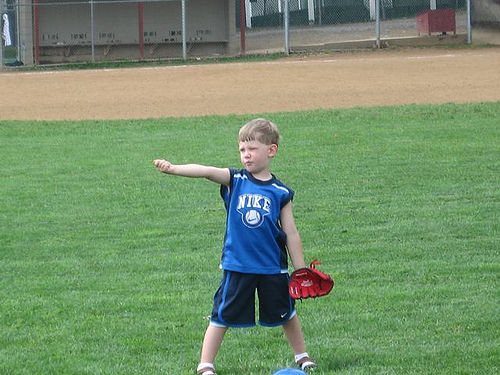Describe the activity that the boy is engaged in. The boy appears to be actively participating in a baseball game, preparing to catch or throw a ball with his red glove ready. 